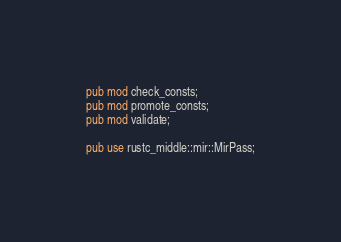<code> <loc_0><loc_0><loc_500><loc_500><_Rust_>pub mod check_consts;
pub mod promote_consts;
pub mod validate;

pub use rustc_middle::mir::MirPass;
</code> 